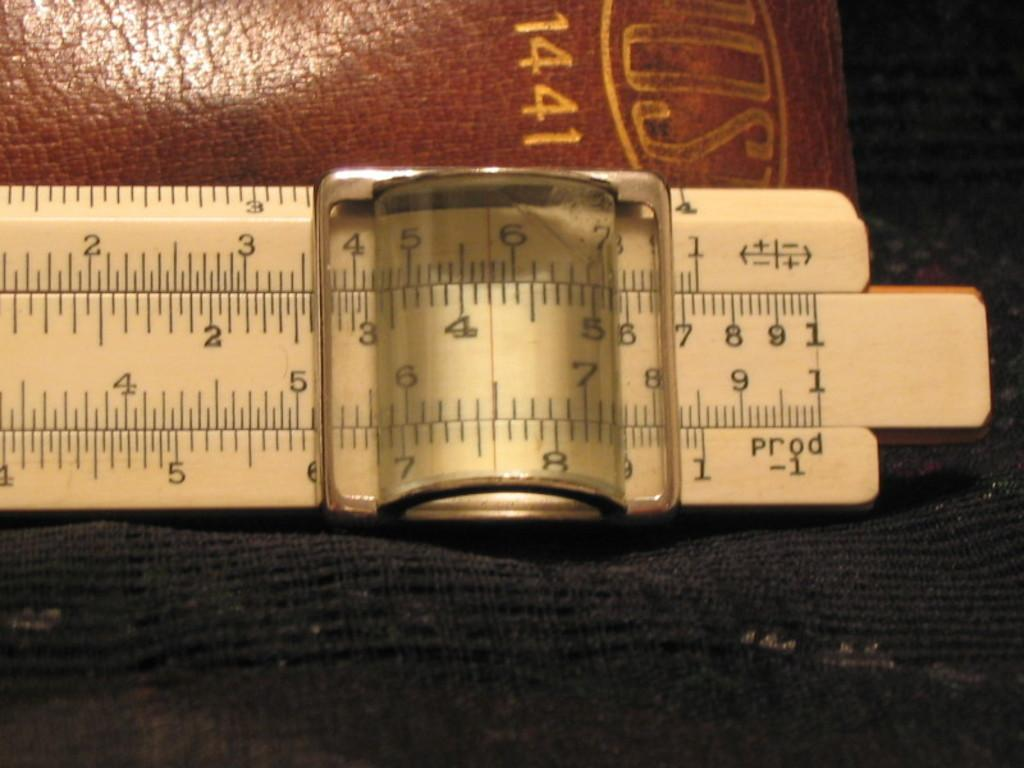<image>
Describe the image concisely. A slide rule in front of a leather bound book that says 1441. 